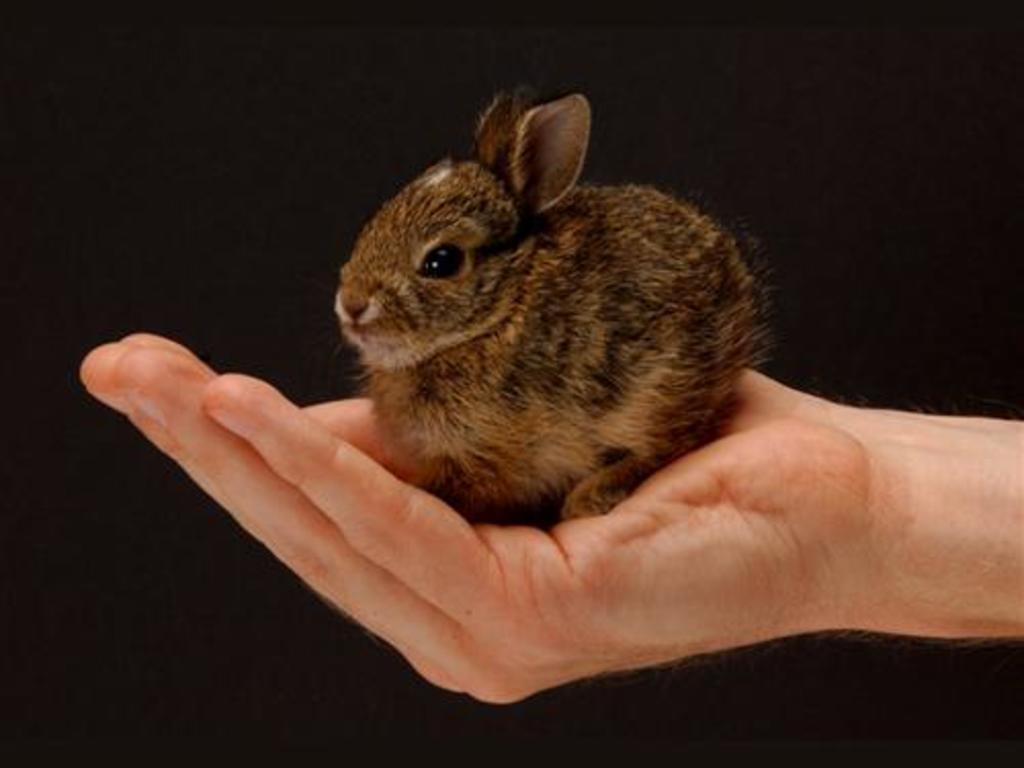Describe this image in one or two sentences. We can see rabbit on hand. 